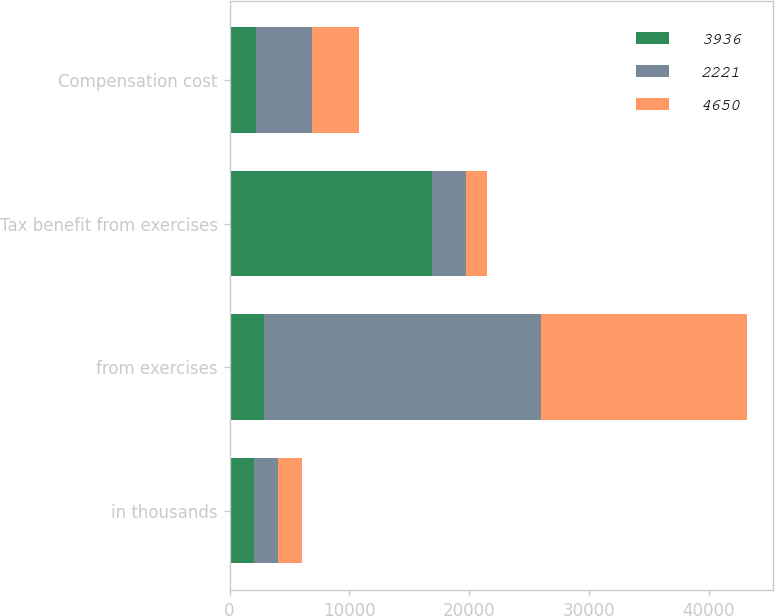Convert chart to OTSL. <chart><loc_0><loc_0><loc_500><loc_500><stacked_bar_chart><ecel><fcel>in thousands<fcel>from exercises<fcel>Tax benefit from exercises<fcel>Compensation cost<nl><fcel>3936<fcel>2015<fcel>2844<fcel>16920<fcel>2221<nl><fcel>2221<fcel>2014<fcel>23199<fcel>2844<fcel>4650<nl><fcel>4650<fcel>2013<fcel>17156<fcel>1770<fcel>3936<nl></chart> 